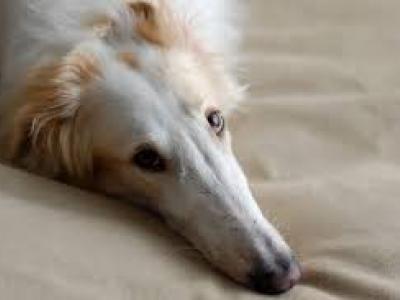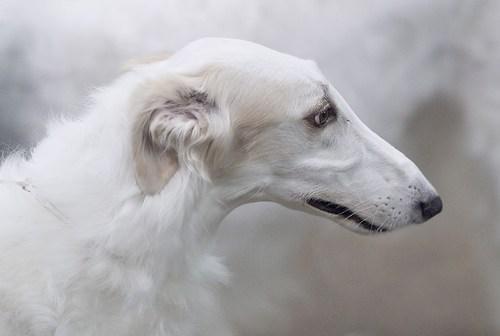The first image is the image on the left, the second image is the image on the right. Evaluate the accuracy of this statement regarding the images: "More than one quarter of the dogs has their mouth open.". Is it true? Answer yes or no. No. The first image is the image on the left, the second image is the image on the right. Given the left and right images, does the statement "There are at most two dogs." hold true? Answer yes or no. Yes. 